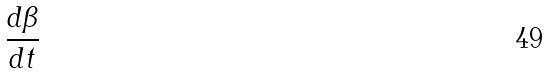Convert formula to latex. <formula><loc_0><loc_0><loc_500><loc_500>\frac { d \beta } { d t }</formula> 